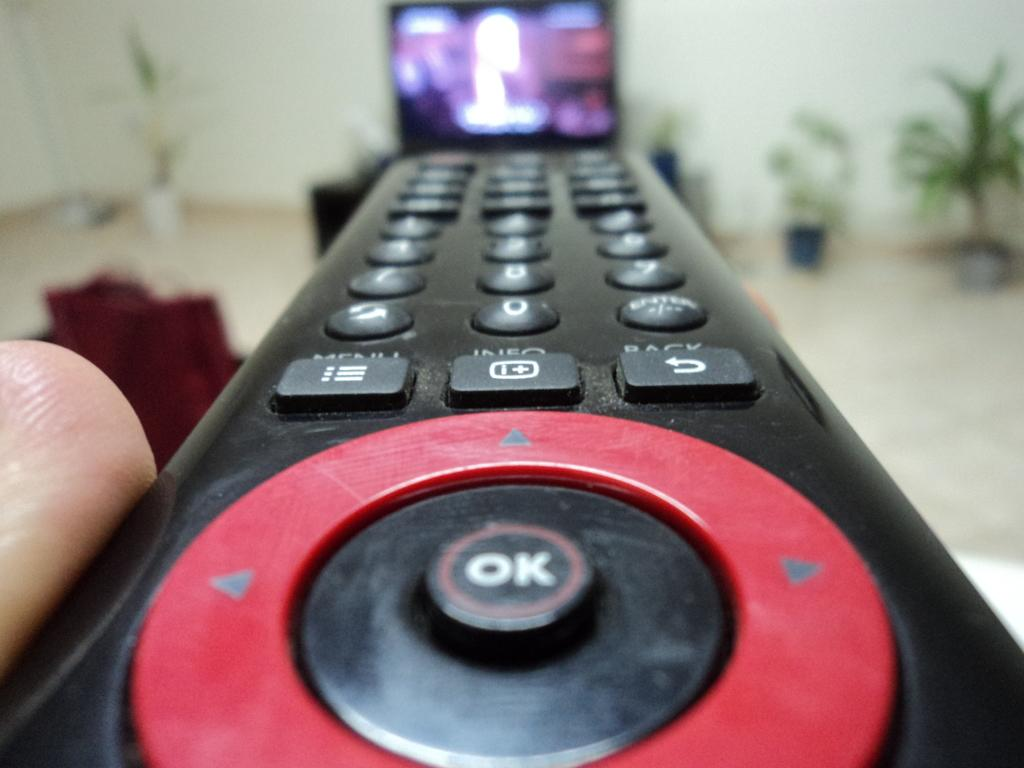<image>
Write a terse but informative summary of the picture. close up of tv remote that has an ok button with a red circle around it and it is pointed at a tv 